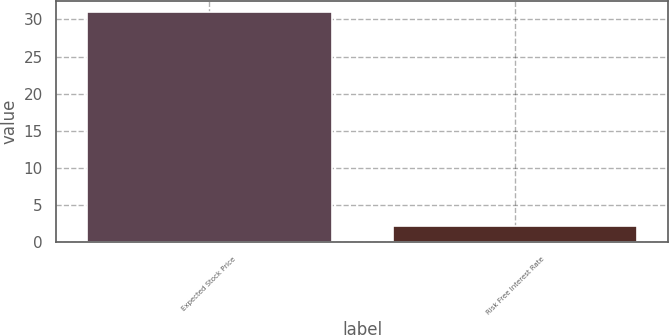Convert chart. <chart><loc_0><loc_0><loc_500><loc_500><bar_chart><fcel>Expected Stock Price<fcel>Risk Free Interest Rate<nl><fcel>31<fcel>2.2<nl></chart> 